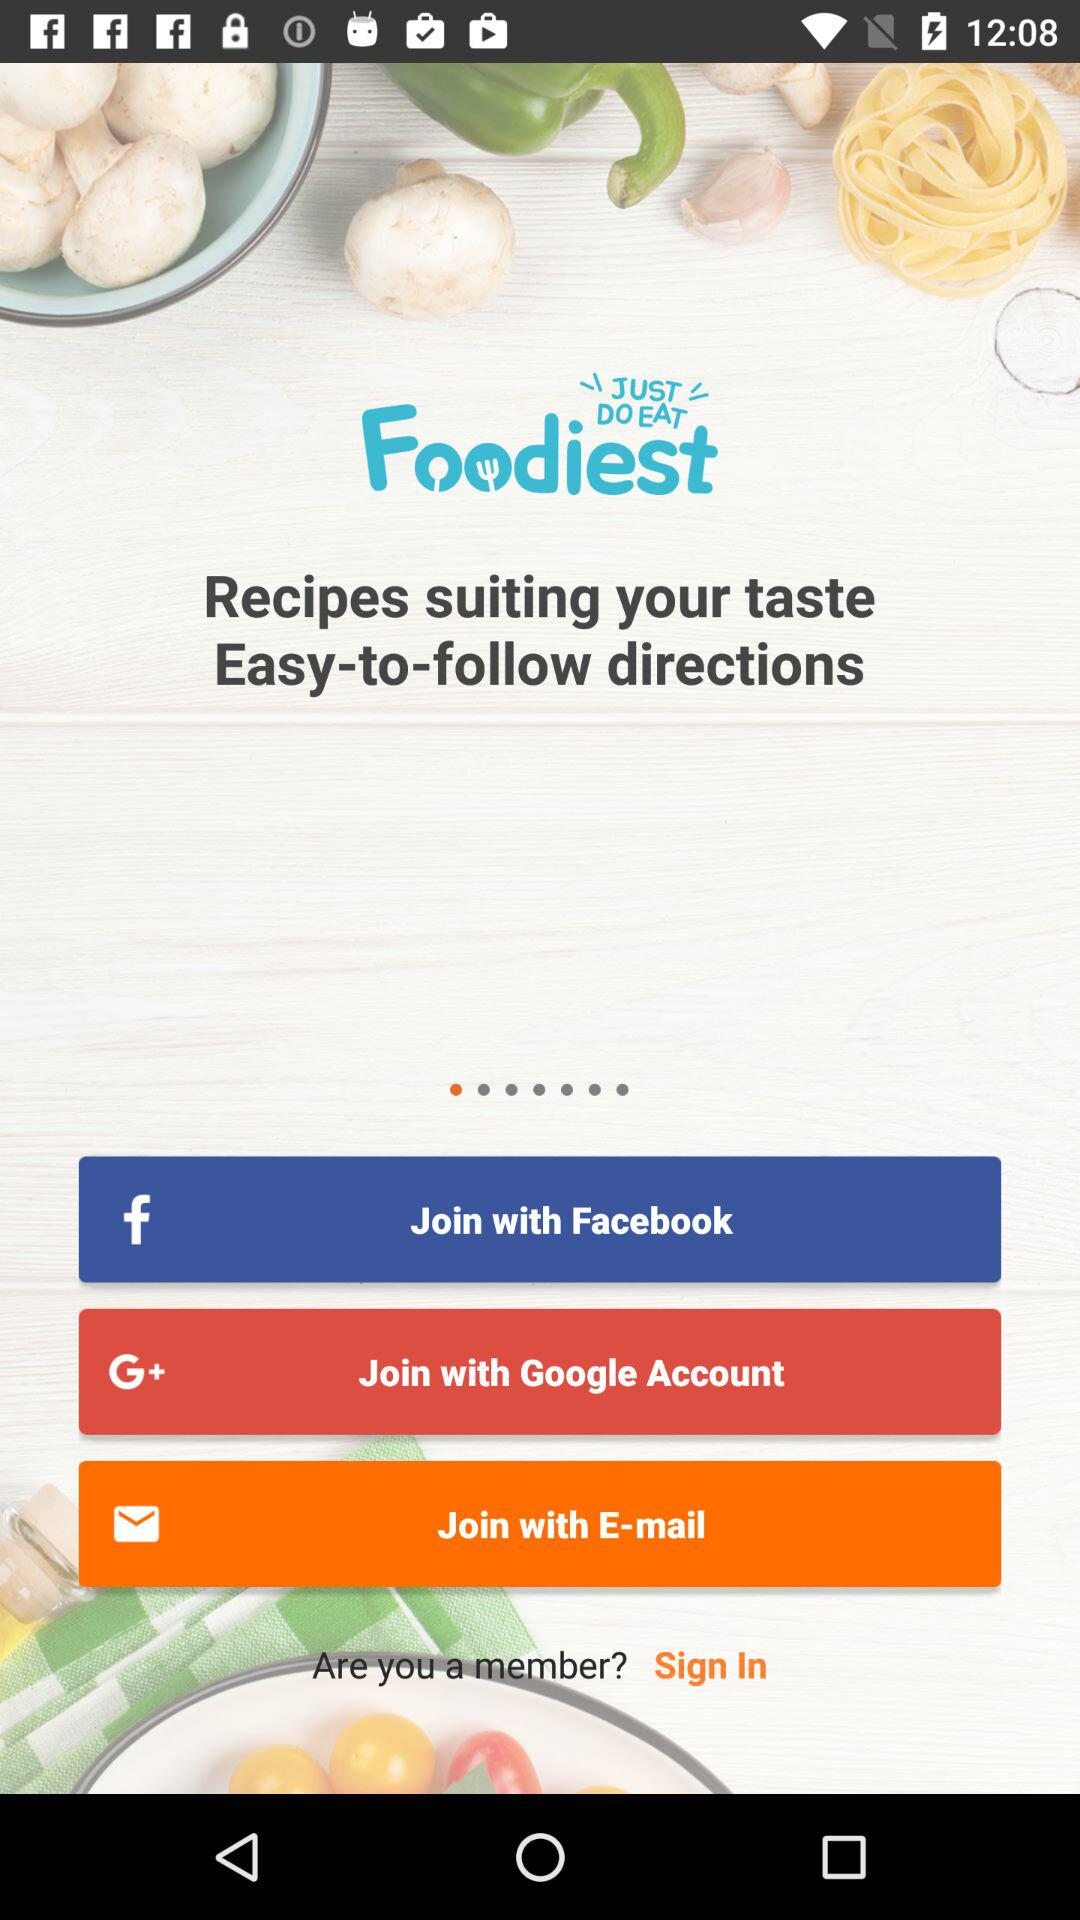What is the application name? The application name is "Foodiest". 